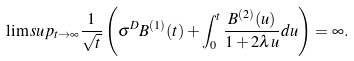<formula> <loc_0><loc_0><loc_500><loc_500>\lim s u p _ { t \to \infty } \frac { 1 } { \sqrt { t } } \left ( \sigma ^ { D } B ^ { ( 1 ) } ( t ) + \int _ { 0 } ^ { t } \frac { B ^ { ( 2 ) } ( u ) } { 1 + 2 \lambda u } d u \right ) = \infty .</formula> 